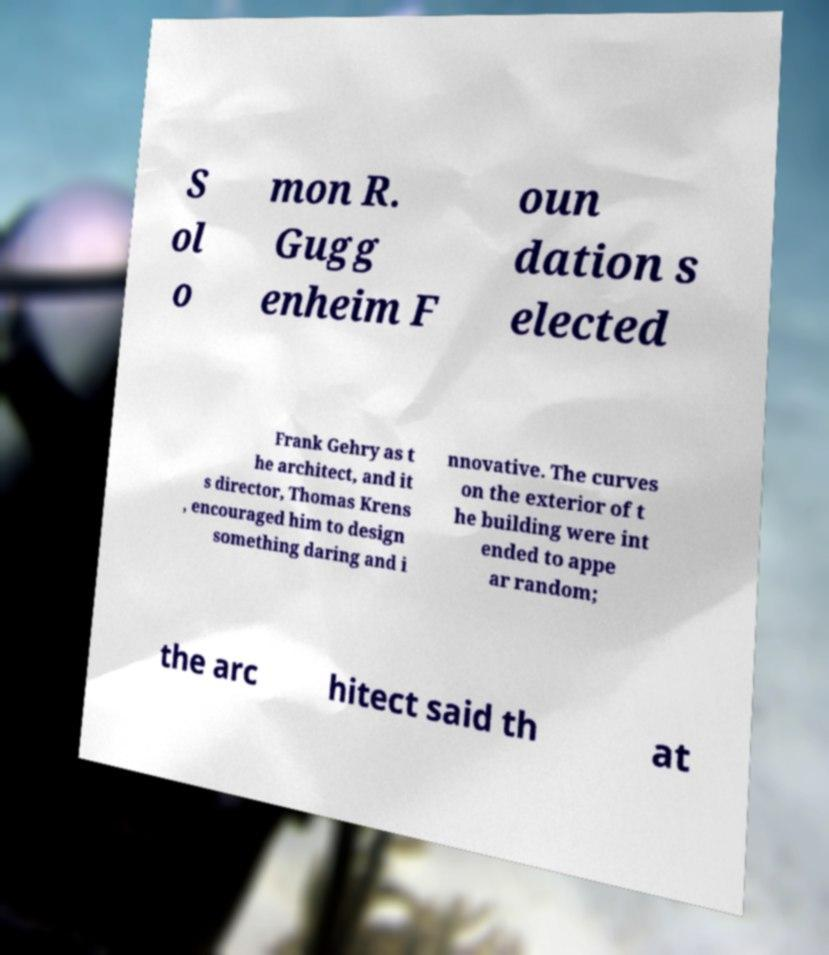For documentation purposes, I need the text within this image transcribed. Could you provide that? S ol o mon R. Gugg enheim F oun dation s elected Frank Gehry as t he architect, and it s director, Thomas Krens , encouraged him to design something daring and i nnovative. The curves on the exterior of t he building were int ended to appe ar random; the arc hitect said th at 